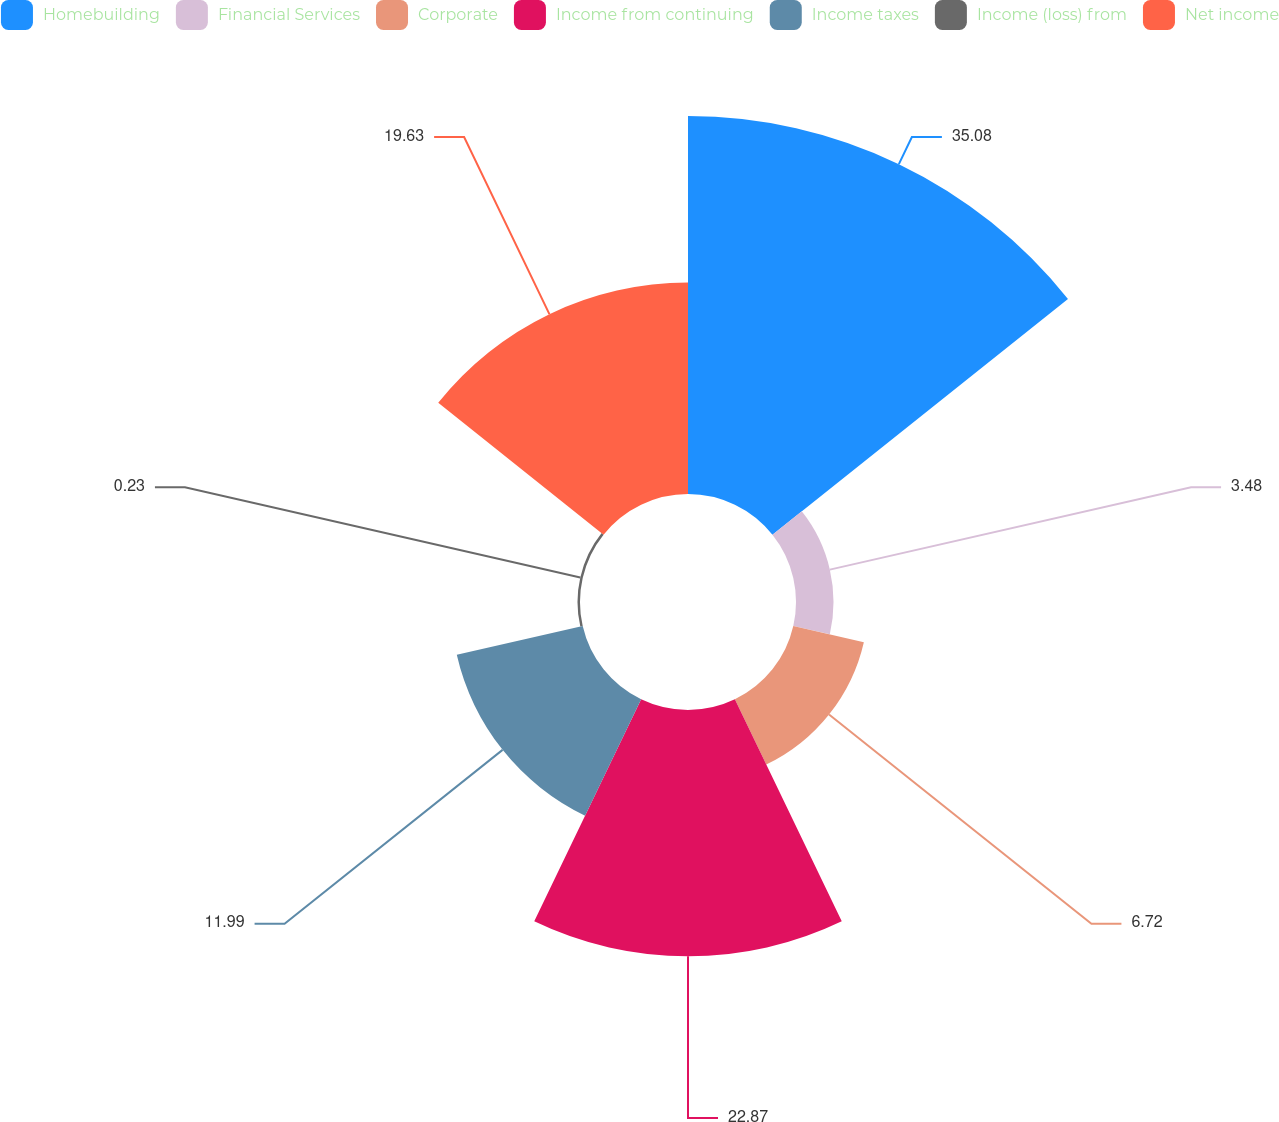Convert chart to OTSL. <chart><loc_0><loc_0><loc_500><loc_500><pie_chart><fcel>Homebuilding<fcel>Financial Services<fcel>Corporate<fcel>Income from continuing<fcel>Income taxes<fcel>Income (loss) from<fcel>Net income<nl><fcel>35.09%<fcel>3.48%<fcel>6.72%<fcel>22.87%<fcel>11.99%<fcel>0.23%<fcel>19.63%<nl></chart> 